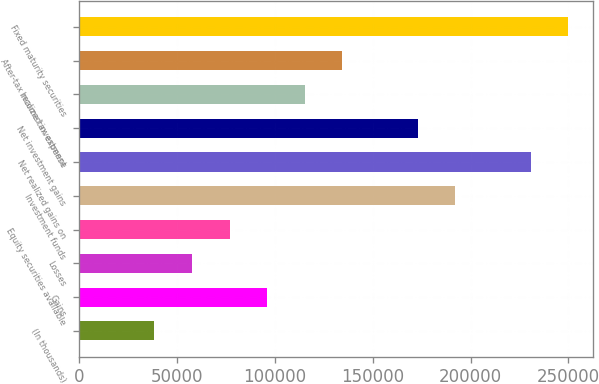Convert chart to OTSL. <chart><loc_0><loc_0><loc_500><loc_500><bar_chart><fcel>(In thousands)<fcel>Gains<fcel>Losses<fcel>Equity securities available<fcel>Investment funds<fcel>Net realized gains on<fcel>Net investment gains<fcel>Income tax expense<fcel>After-tax realized investment<fcel>Fixed maturity securities<nl><fcel>38467.6<fcel>96112<fcel>57682.4<fcel>76897.2<fcel>192186<fcel>230616<fcel>172971<fcel>115327<fcel>134542<fcel>249830<nl></chart> 